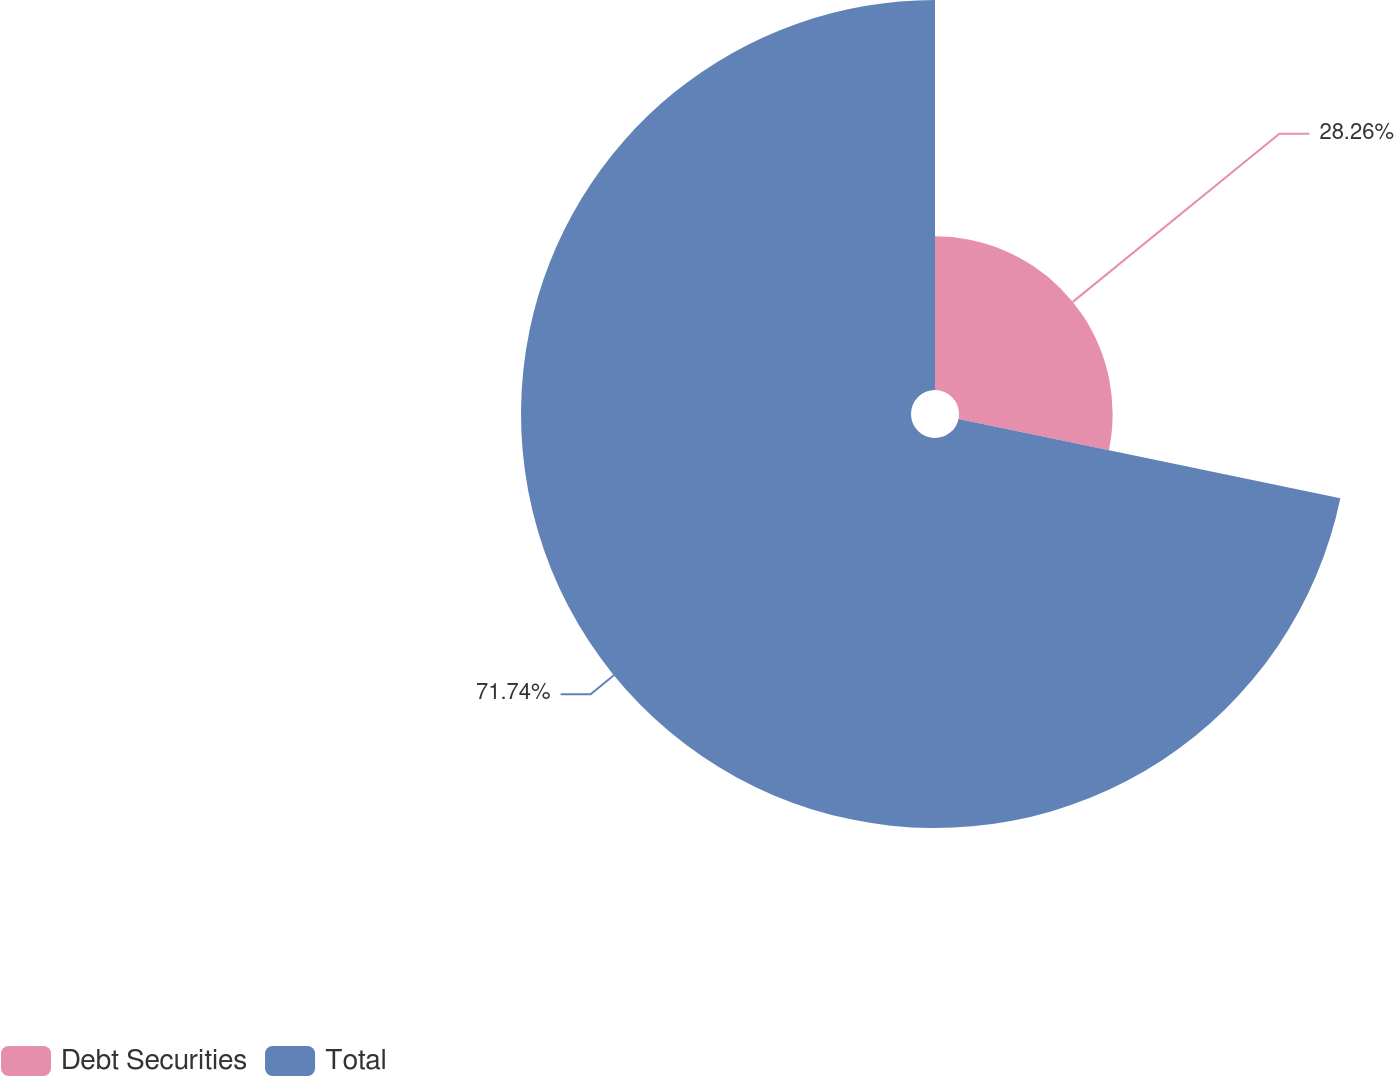Convert chart. <chart><loc_0><loc_0><loc_500><loc_500><pie_chart><fcel>Debt Securities<fcel>Total<nl><fcel>28.26%<fcel>71.74%<nl></chart> 